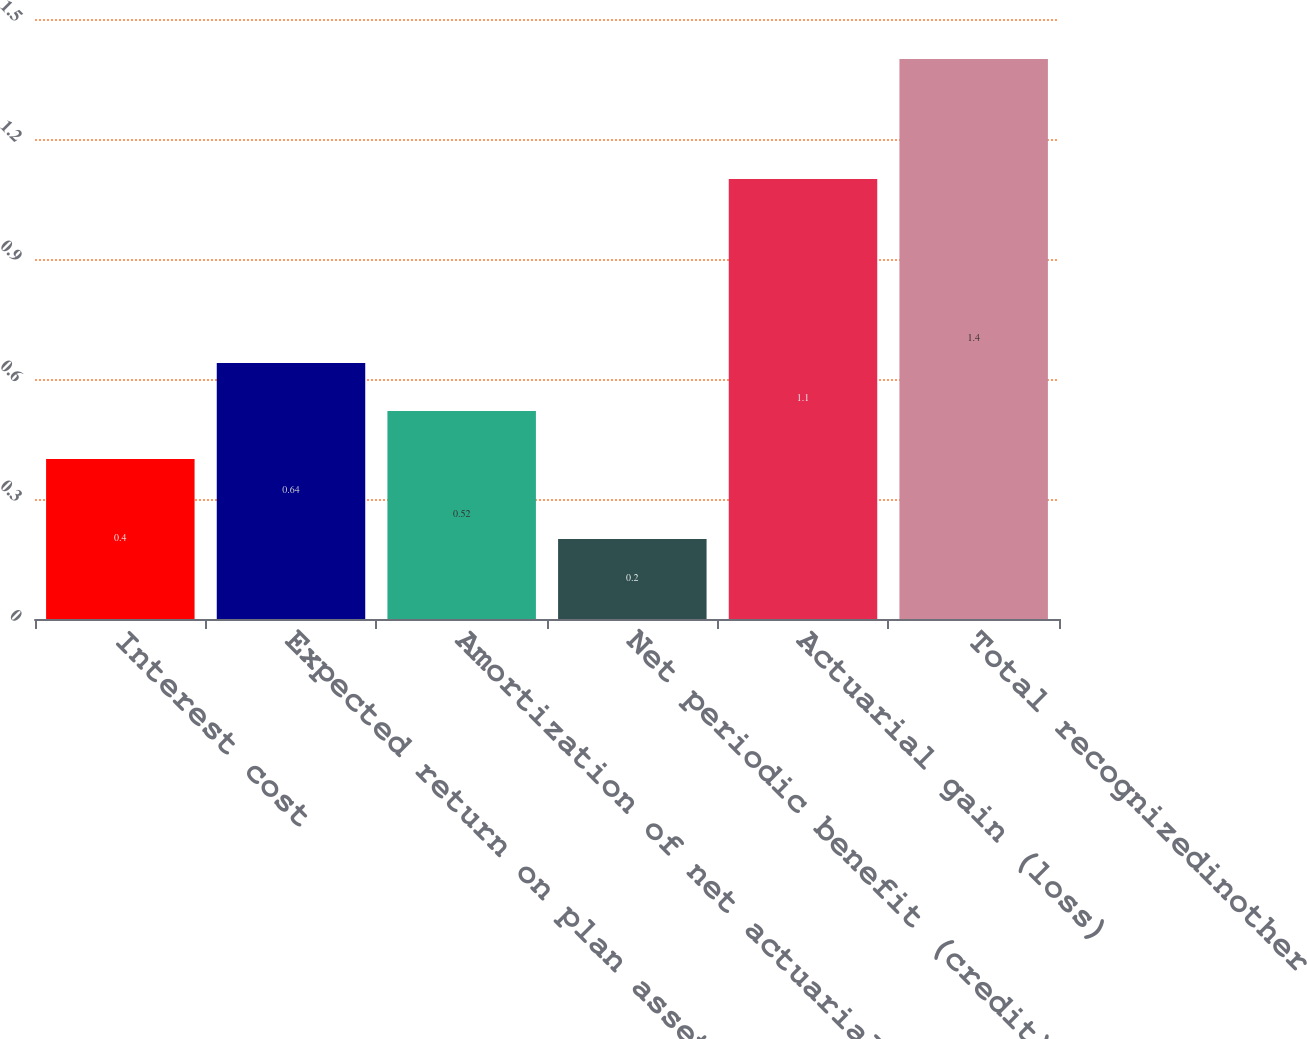Convert chart to OTSL. <chart><loc_0><loc_0><loc_500><loc_500><bar_chart><fcel>Interest cost<fcel>Expected return on plan assets<fcel>Amortization of net actuarial<fcel>Net periodic benefit (credit)<fcel>Actuarial gain (loss)<fcel>Total recognizedinother<nl><fcel>0.4<fcel>0.64<fcel>0.52<fcel>0.2<fcel>1.1<fcel>1.4<nl></chart> 